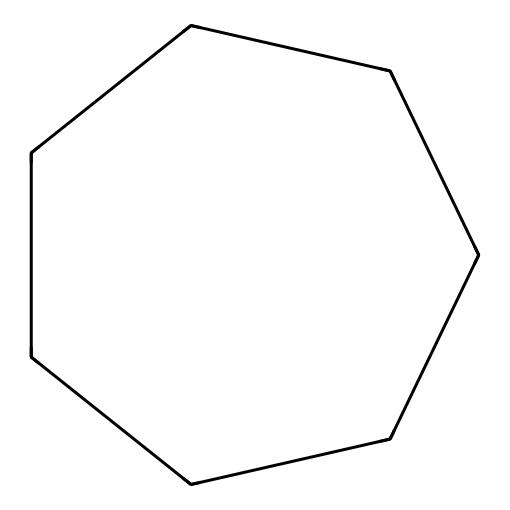What is the name of this compound? The compound represented by the SMILES C1CCCCCC1 is known as cycloheptane. The "C" stands for carbon atoms and "1" indicates the beginning and end of a ring structure, confirming it is a cyclic compound with 7 carbon atoms.
Answer: cycloheptane How many carbon atoms are in cycloheptane? The structure displays 7 carbon atoms arranged in a cycle. By counting the "C" in the SMILES representation, it is clear that there are 7 carbon atoms present.
Answer: 7 What type of hydrocarbon is cycloheptane? Cycloheptane belongs to the category of cycloalkanes, which are saturated cyclic hydrocarbons. The absence of double or triple bonds, combined with every carbon being bonded to hydrogen, qualifies it as a cycloalkane.
Answer: cycloalkane How many hydrogen atoms are in cycloheptane? In cycloheptane, the formula can be determined by using the general formula for cycloalkanes, CnH2n. For n=7, H = 2(7) = 14. Therefore, it contains 14 hydrogen atoms.
Answer: 14 Is cycloheptane a saturated or unsaturated compound? Cycloheptane is a saturated compound because it contains only single bonds between the carbon atoms. The term "saturated" indicates that it has the maximum number of hydrogen atoms bonded to the carbon chain without any double or triple bonds.
Answer: saturated What does the cyclic structure imply about the stability of cycloheptane? The cyclic structure of cycloheptane can imply some degree of strain due to the 7-membered ring, but overall, its stability is moderate compared to larger and smaller rings. Cycloheptane does not have as much ring strain as smaller cycloalkanes but more than larger ones, resulting in reasonable stability.
Answer: moderate stability 